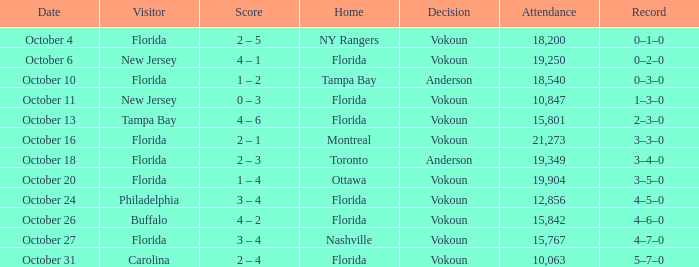Which team emerged victorious when the guest was carolina? Vokoun. 